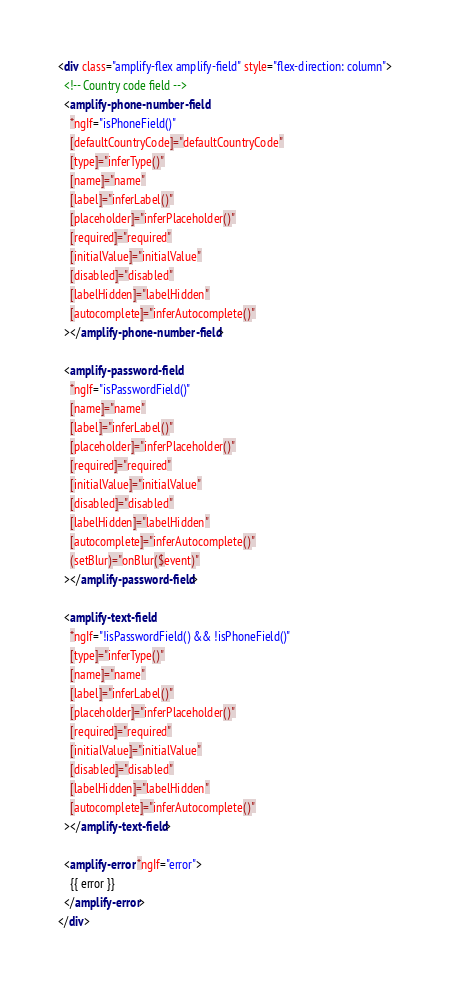<code> <loc_0><loc_0><loc_500><loc_500><_HTML_><div class="amplify-flex amplify-field" style="flex-direction: column">
  <!-- Country code field -->
  <amplify-phone-number-field
    *ngIf="isPhoneField()"
    [defaultCountryCode]="defaultCountryCode"
    [type]="inferType()"
    [name]="name"
    [label]="inferLabel()"
    [placeholder]="inferPlaceholder()"
    [required]="required"
    [initialValue]="initialValue"
    [disabled]="disabled"
    [labelHidden]="labelHidden"
    [autocomplete]="inferAutocomplete()"
  ></amplify-phone-number-field>

  <amplify-password-field
    *ngIf="isPasswordField()"
    [name]="name"
    [label]="inferLabel()"
    [placeholder]="inferPlaceholder()"
    [required]="required"
    [initialValue]="initialValue"
    [disabled]="disabled"
    [labelHidden]="labelHidden"
    [autocomplete]="inferAutocomplete()"
    (setBlur)="onBlur($event)"
  ></amplify-password-field>

  <amplify-text-field
    *ngIf="!isPasswordField() && !isPhoneField()"
    [type]="inferType()"
    [name]="name"
    [label]="inferLabel()"
    [placeholder]="inferPlaceholder()"
    [required]="required"
    [initialValue]="initialValue"
    [disabled]="disabled"
    [labelHidden]="labelHidden"
    [autocomplete]="inferAutocomplete()"
  ></amplify-text-field>

  <amplify-error *ngIf="error">
    {{ error }}
  </amplify-error>
</div>
</code> 